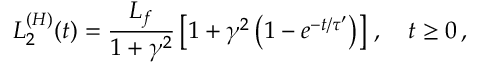Convert formula to latex. <formula><loc_0><loc_0><loc_500><loc_500>L _ { 2 } ^ { ( H ) } ( t ) = \frac { L _ { f } } { 1 + \gamma ^ { 2 } } \left [ 1 + \gamma ^ { 2 } \left ( 1 - e ^ { - t / \tau ^ { \prime } } \right ) \right ] \, , \quad t \geq 0 \, ,</formula> 